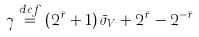Convert formula to latex. <formula><loc_0><loc_0><loc_500><loc_500>\gamma \overset { d e f } { = } \left ( 2 ^ { \bar { r } } + 1 \right ) \bar { \sigma } _ { V } + 2 ^ { \bar { r } } - 2 ^ { - \bar { r } }</formula> 